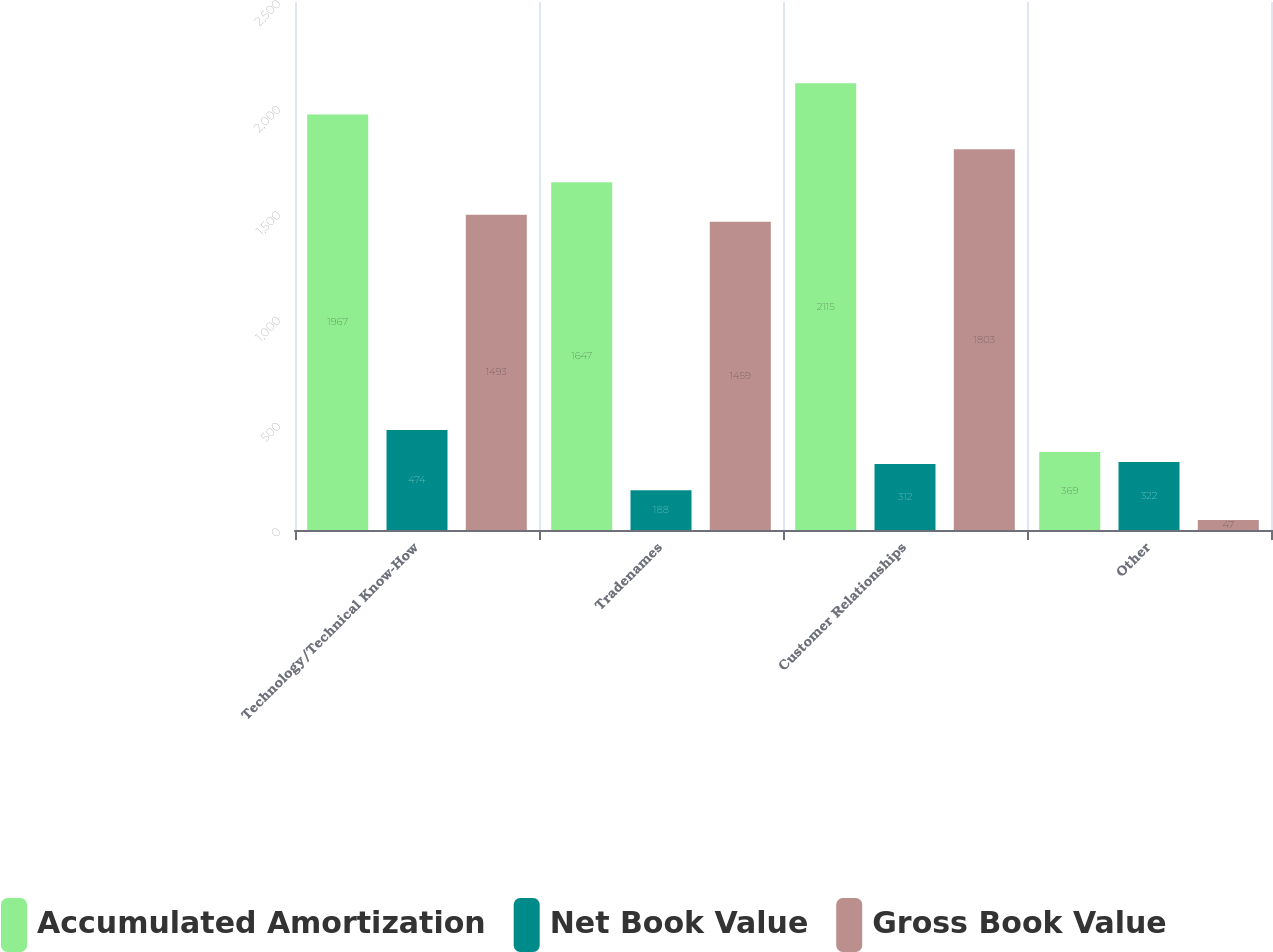Convert chart. <chart><loc_0><loc_0><loc_500><loc_500><stacked_bar_chart><ecel><fcel>Technology/Technical Know-How<fcel>Tradenames<fcel>Customer Relationships<fcel>Other<nl><fcel>Accumulated Amortization<fcel>1967<fcel>1647<fcel>2115<fcel>369<nl><fcel>Net Book Value<fcel>474<fcel>188<fcel>312<fcel>322<nl><fcel>Gross Book Value<fcel>1493<fcel>1459<fcel>1803<fcel>47<nl></chart> 